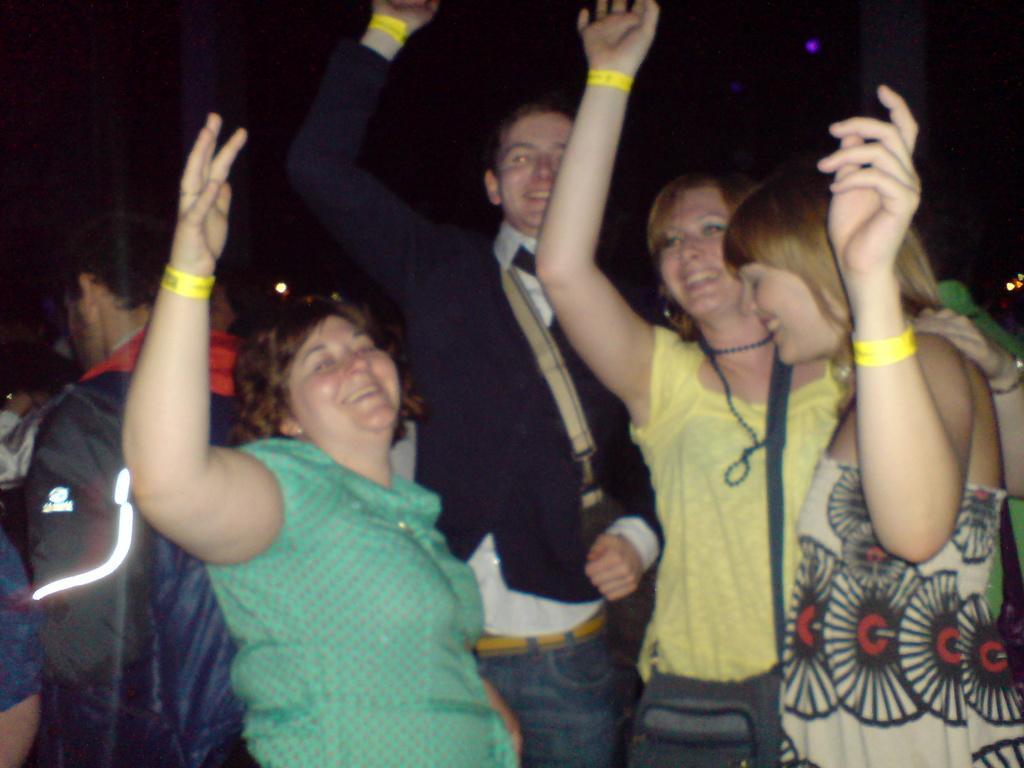In one or two sentences, can you explain what this image depicts? In this picture we can see a group of people standing and smiling, bags and in the background it is dark. 